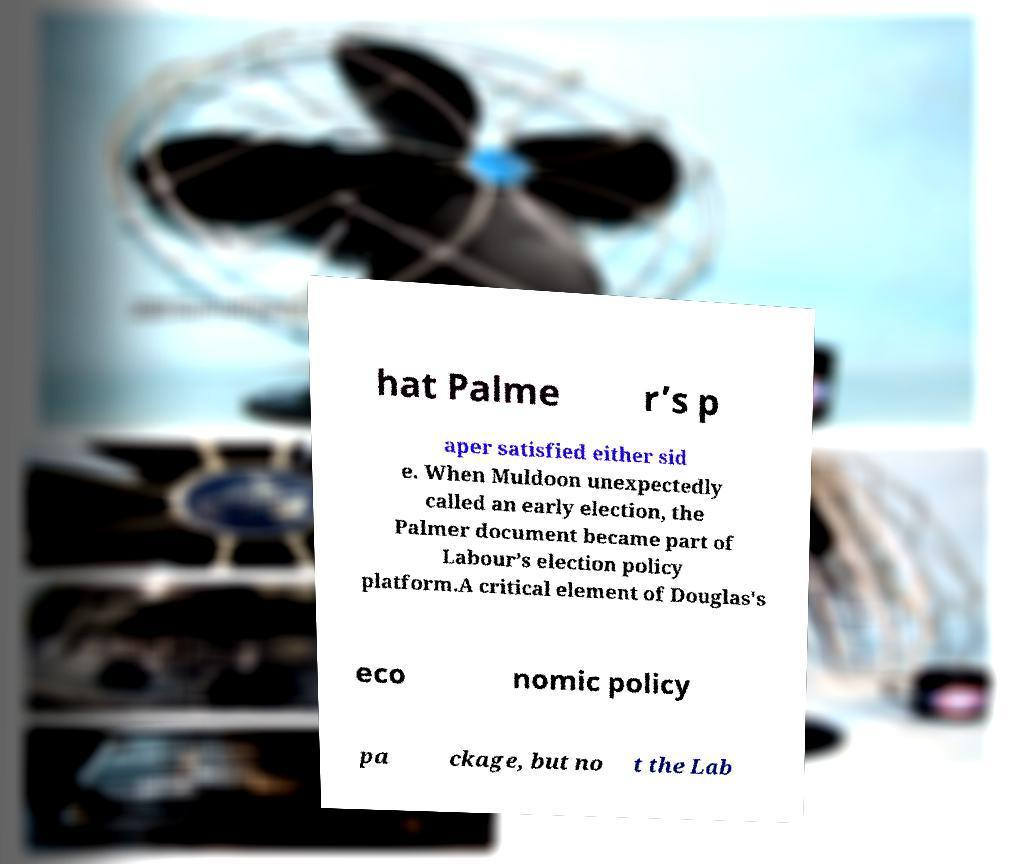Can you read and provide the text displayed in the image?This photo seems to have some interesting text. Can you extract and type it out for me? hat Palme r’s p aper satisfied either sid e. When Muldoon unexpectedly called an early election, the Palmer document became part of Labour’s election policy platform.A critical element of Douglas's eco nomic policy pa ckage, but no t the Lab 